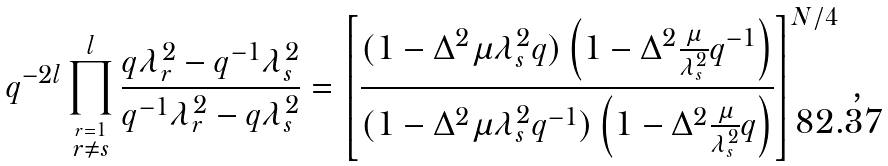Convert formula to latex. <formula><loc_0><loc_0><loc_500><loc_500>q ^ { - 2 l } \prod _ { \stackrel { r = 1 } { r \not = s } } ^ { l } \frac { q \lambda _ { r } ^ { 2 } - q ^ { - 1 } \lambda _ { s } ^ { 2 } } { q ^ { - 1 } \lambda _ { r } ^ { 2 } - q \lambda _ { s } ^ { 2 } } = \left [ \frac { ( 1 - \Delta ^ { 2 } \mu \lambda _ { s } ^ { 2 } q ) \left ( 1 - \Delta ^ { 2 } \frac { \mu } { \lambda _ { s } ^ { 2 } } q ^ { - 1 } \right ) } { ( 1 - \Delta ^ { 2 } \mu \lambda _ { s } ^ { 2 } q ^ { - 1 } ) \left ( 1 - \Delta ^ { 2 } \frac { \mu } { \lambda _ { s } ^ { 2 } } q \right ) } \right ] ^ { N / 4 } \, ,</formula> 